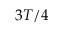Convert formula to latex. <formula><loc_0><loc_0><loc_500><loc_500>3 T / 4</formula> 